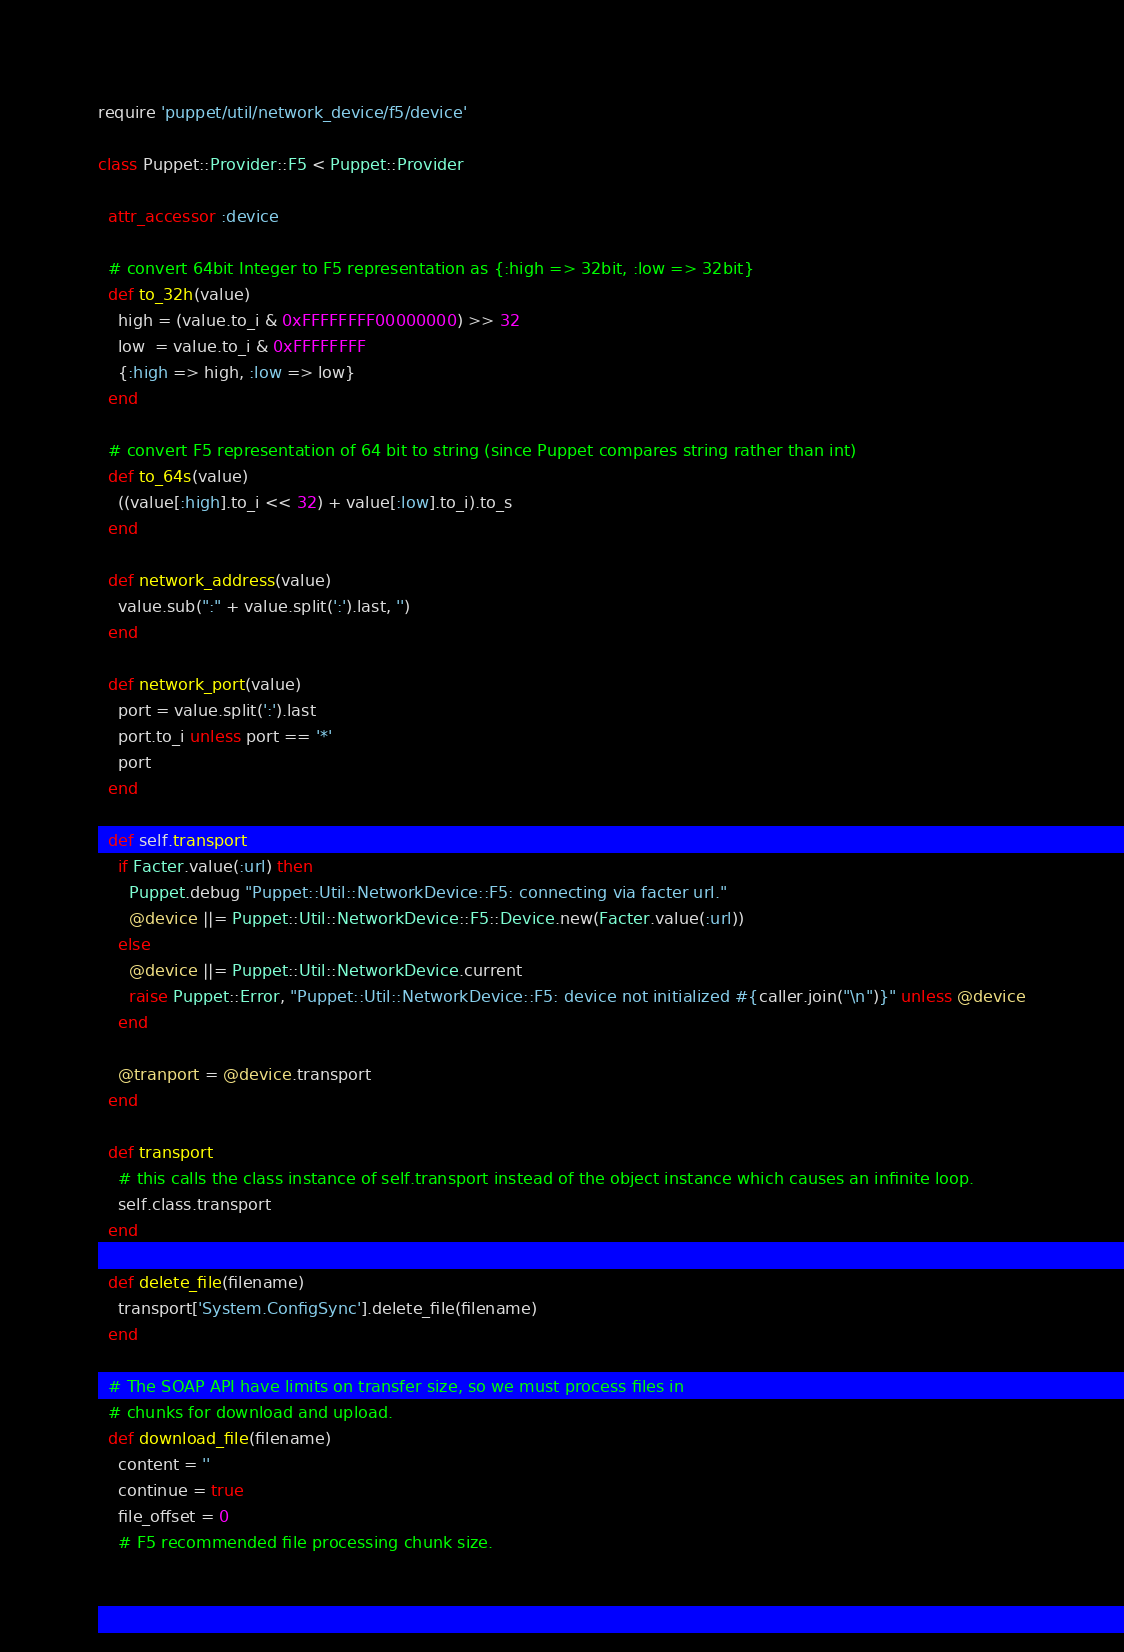Convert code to text. <code><loc_0><loc_0><loc_500><loc_500><_Ruby_>require 'puppet/util/network_device/f5/device'

class Puppet::Provider::F5 < Puppet::Provider

  attr_accessor :device

  # convert 64bit Integer to F5 representation as {:high => 32bit, :low => 32bit}
  def to_32h(value)
    high = (value.to_i & 0xFFFFFFFF00000000) >> 32
    low  = value.to_i & 0xFFFFFFFF
    {:high => high, :low => low}
  end

  # convert F5 representation of 64 bit to string (since Puppet compares string rather than int)
  def to_64s(value)
    ((value[:high].to_i << 32) + value[:low].to_i).to_s
  end

  def network_address(value)
    value.sub(":" + value.split(':').last, '')
  end

  def network_port(value)
    port = value.split(':').last
    port.to_i unless port == '*'
    port
  end

  def self.transport
    if Facter.value(:url) then
      Puppet.debug "Puppet::Util::NetworkDevice::F5: connecting via facter url."
      @device ||= Puppet::Util::NetworkDevice::F5::Device.new(Facter.value(:url))
    else
      @device ||= Puppet::Util::NetworkDevice.current
      raise Puppet::Error, "Puppet::Util::NetworkDevice::F5: device not initialized #{caller.join("\n")}" unless @device
    end

    @tranport = @device.transport
  end

  def transport
    # this calls the class instance of self.transport instead of the object instance which causes an infinite loop.
    self.class.transport
  end

  def delete_file(filename)
    transport['System.ConfigSync'].delete_file(filename)
  end

  # The SOAP API have limits on transfer size, so we must process files in
  # chunks for download and upload.
  def download_file(filename)
    content = ''
    continue = true
    file_offset = 0
    # F5 recommended file processing chunk size.</code> 